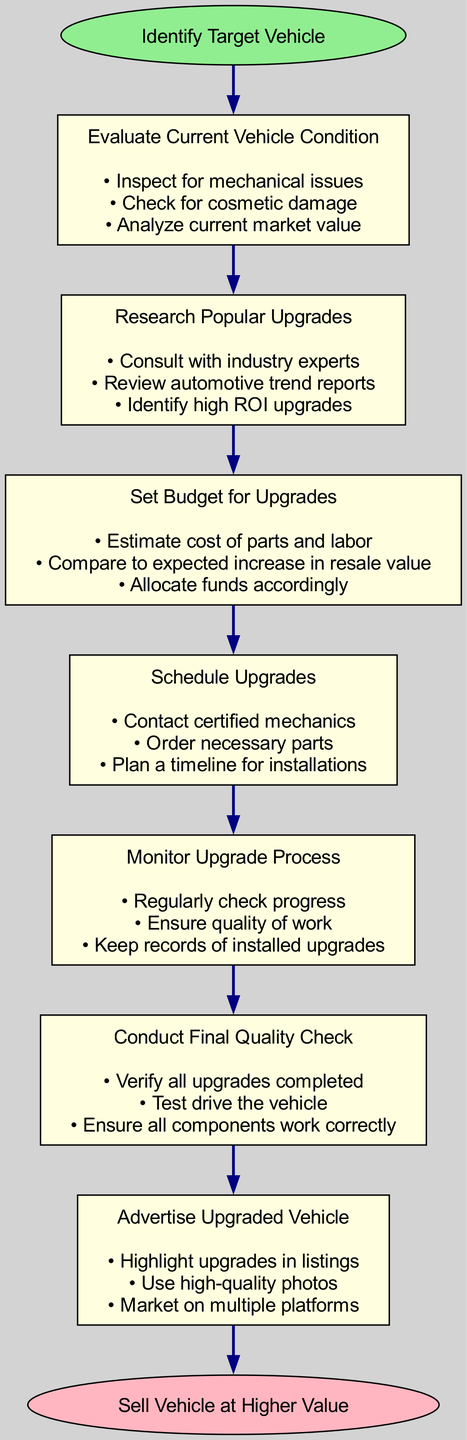What is the first step in the process? The diagram starts with the "Identify Target Vehicle" step, which is clearly marked as the initial action in the flowchart.
Answer: Identify Target Vehicle How many total steps are there in the diagram? The diagram lists a total of 7 steps that are sequentially connected from start to finish.
Answer: 7 What action is included in the "Evaluate Current Vehicle Condition"? The diagram states that one action is "Inspect for mechanical issues", which is part of this step's detailed actions.
Answer: Inspect for mechanical issues What action should be taken during the "Schedule Upgrades"? One action mentioned in the "Schedule Upgrades" step is "Contact certified mechanics", highlighting the necessary coordination required for upgrades.
Answer: Contact certified mechanics Which step comes immediately after "Research Popular Upgrades"? Following "Research Popular Upgrades," the next step indicated in the diagram is "Set Budget for Upgrades," showing a direct progression in the process.
Answer: Set Budget for Upgrades What is the last action taken before selling the vehicle? The final step before selling the vehicle is to "Advertise Upgraded Vehicle," emphasizing the importance of marketing after all upgrades have been completed.
Answer: Advertise Upgraded Vehicle Which two steps involve checking or verifying something? The "Monitor Upgrade Process" and "Conduct Final Quality Check" both include actions that focus on oversight and ensuring work is done correctly, embodying quality assurance.
Answer: Monitor Upgrade Process, Conduct Final Quality Check What shape is used to represent the starting and ending points in the diagram? Both the starting and ending points are represented by an ellipse shape, which is a standard notation for highlight key process start and end.
Answer: Ellipse 